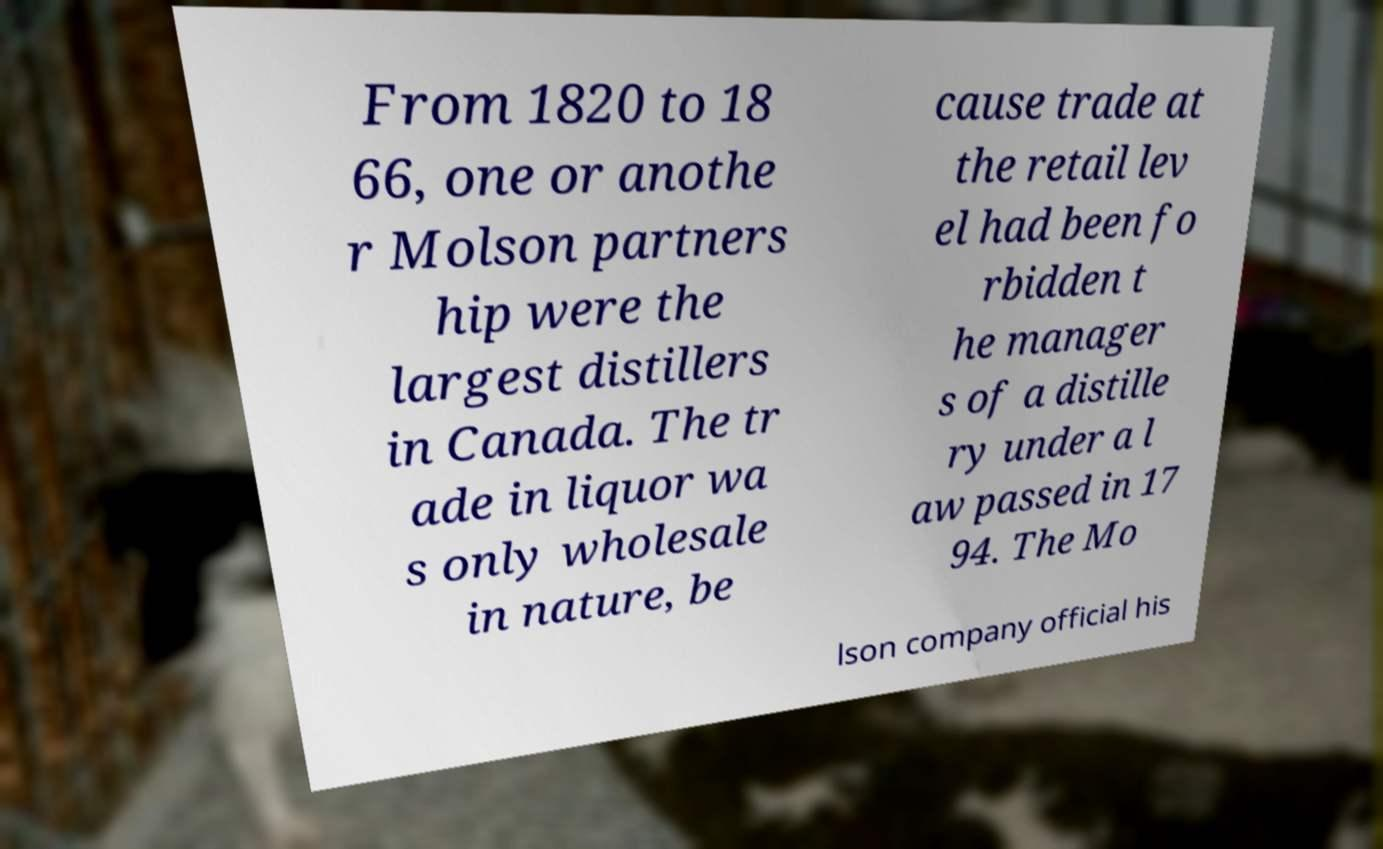Can you read and provide the text displayed in the image?This photo seems to have some interesting text. Can you extract and type it out for me? From 1820 to 18 66, one or anothe r Molson partners hip were the largest distillers in Canada. The tr ade in liquor wa s only wholesale in nature, be cause trade at the retail lev el had been fo rbidden t he manager s of a distille ry under a l aw passed in 17 94. The Mo lson company official his 